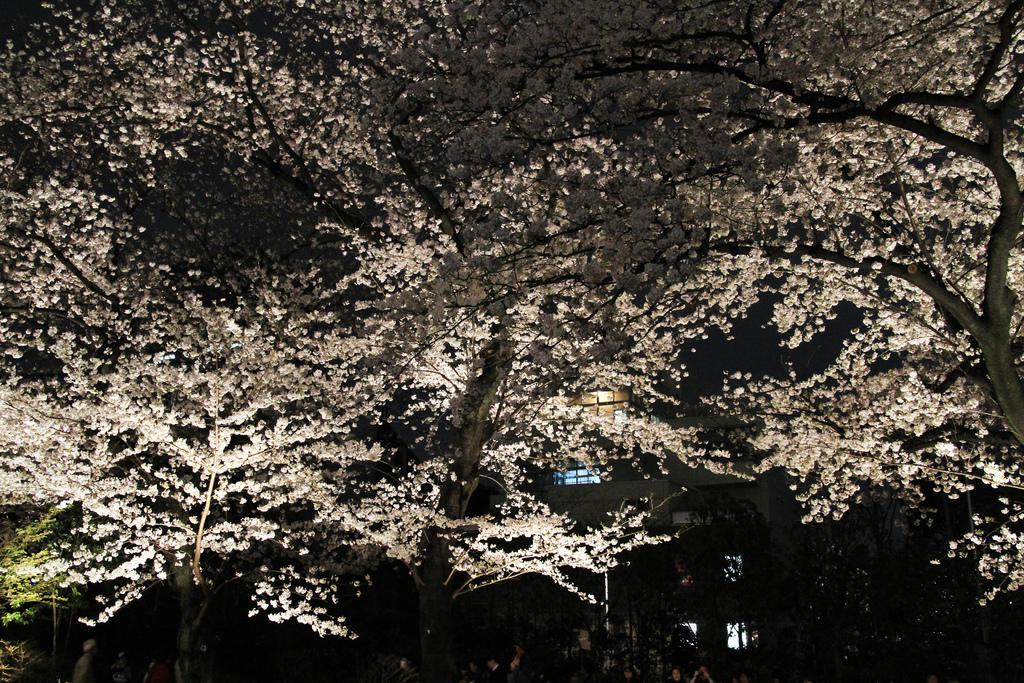What type of natural elements can be seen in the background of the image? There are trees in the background of the image. What type of man-made structures can be seen in the background of the image? There are buildings in the background of the image. What type of feather can be seen on the beggar in the image? There is no beggar or feather present in the image. How does the wash look in the image? There is no reference to a wash or any washing activity in the image. 